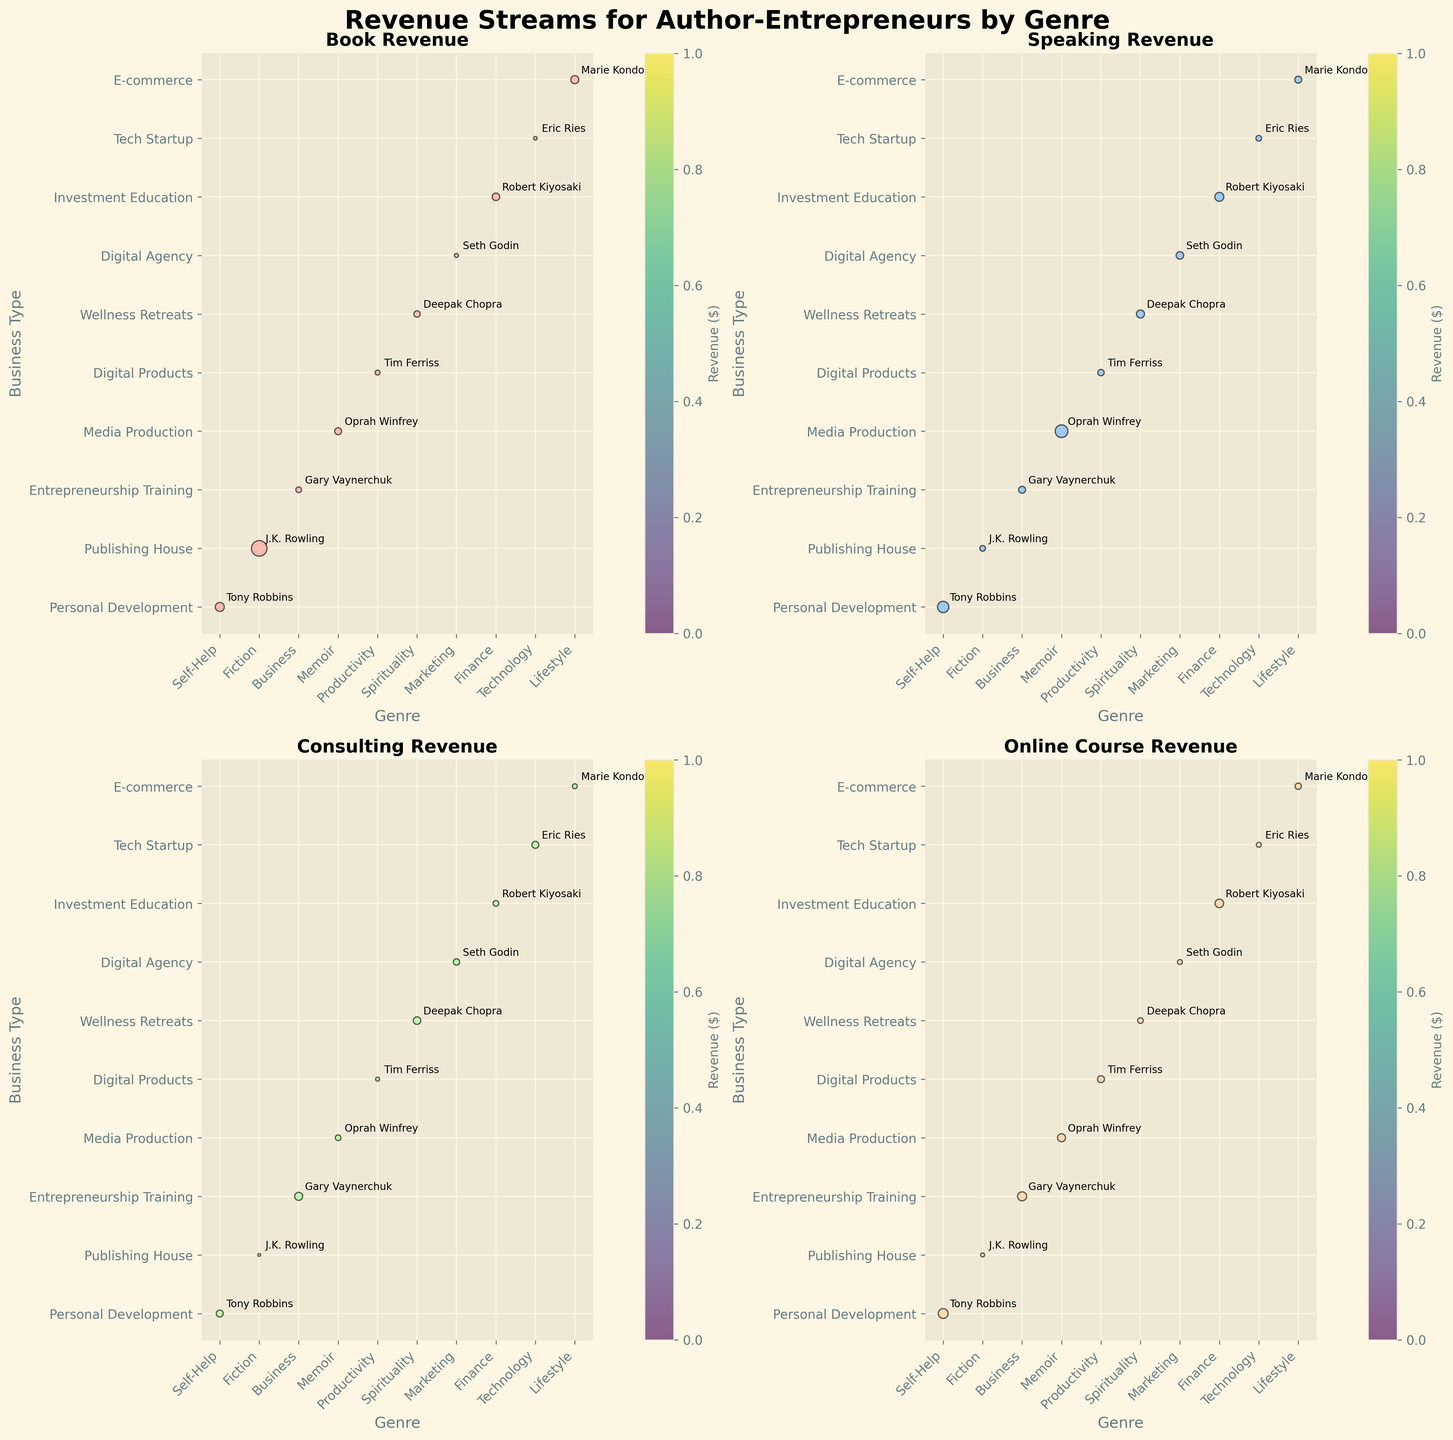What are the genres with the highest Book Revenue? Look at the 'Book Revenue' subplot and identify the bubbles with the largest size. The largest bubble represents J.K. Rowling in the Fiction genre.
Answer: Fiction Which author has the highest Consulting Revenue? Observe the 'Consulting Revenue' subplot and find the largest bubble. The largest bubble corresponds to Gary Vaynerchuk in the Business genre.
Answer: Gary Vaynerchuk What are the business types associated with Tony Robbins? Find Tony Robbins in all subplots. He appears in the 'Personal Development' business type.
Answer: Personal Development How does the Speaking Revenue for Oprah Winfrey compare to Tim Ferriss? Look at the 'Speaking Revenue' subplot and compare the bubble sizes. Oprah Winfrey has a larger bubble than Tim Ferriss.
Answer: Oprah Winfrey has higher Speaking Revenue What is the combined Online Course Revenue for Gary Vaynerchuk and Marie Kondo? Locate both authors in the 'Online Course Revenue' subplot. Add their revenues together (Gary: $5,000,000 + Marie: $2,500,000).
Answer: $7,500,000 In which genre does the author with the highest Speaking Revenue belong? Check the 'Speaking Revenue' subplot for the largest bubble. The largest bubble represents Oprah Winfrey in the Memoir genre.
Answer: Memoir Which author in the Technology genre has the highest revenue in any category? Identify the bubbles in the Technology genre across all subplots. Eric Ries has the largest bubble in 'Consulting Revenue'.
Answer: Eric Ries in Consulting Revenue What is the difference in Book Revenue between Tony Robbins and Deepak Chopra? Compare the Book Revenue bubbles for Tony Robbins and Deepak Chopra. Calculate the difference ($5,000,000 - $2,500,000).
Answer: $2,500,000 How many authors are represented in the Digital Products business type? Count the number of data points labeled 'Digital Products' across all subplots. Tim Ferriss is the only one.
Answer: 1 Which genre has the most diverse revenue streams across multiple business types? Examine the number of different business types within each genre shown in all subplots. Fiction and Memoir appear across multiple business types.
Answer: Fiction and Memoir 